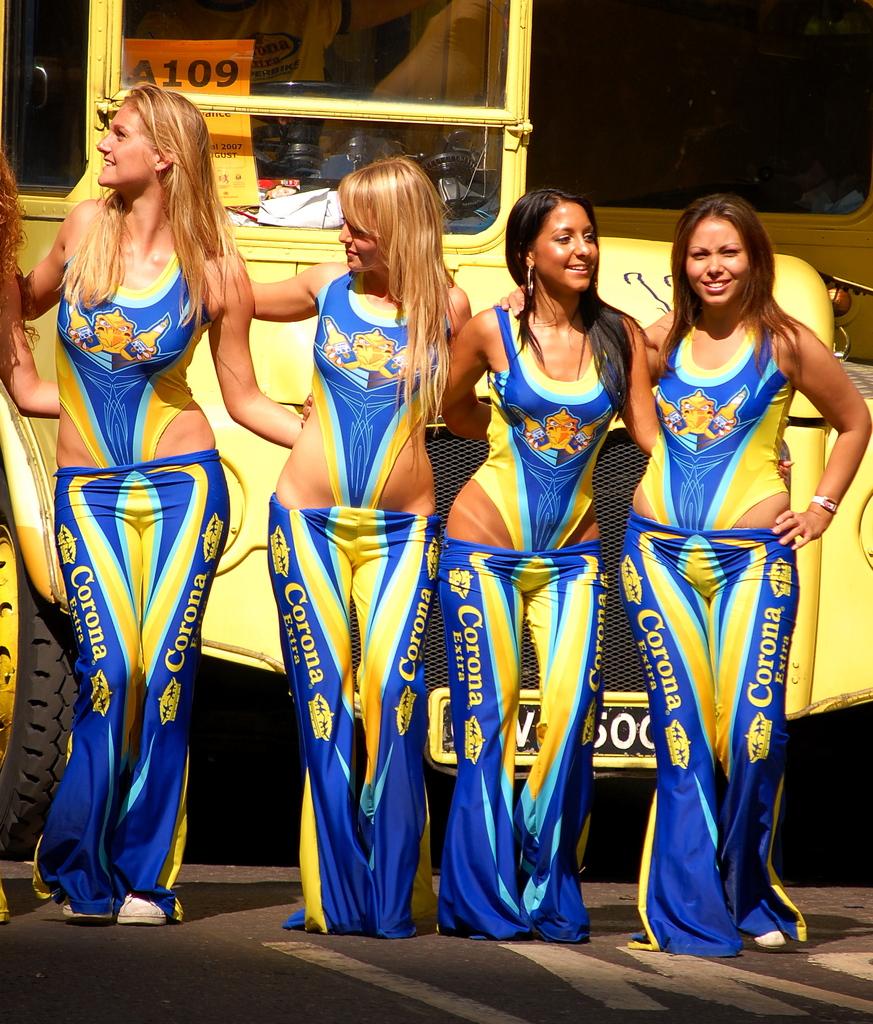What is the number mentioned in the building behind the women?
Your answer should be compact. A109. 